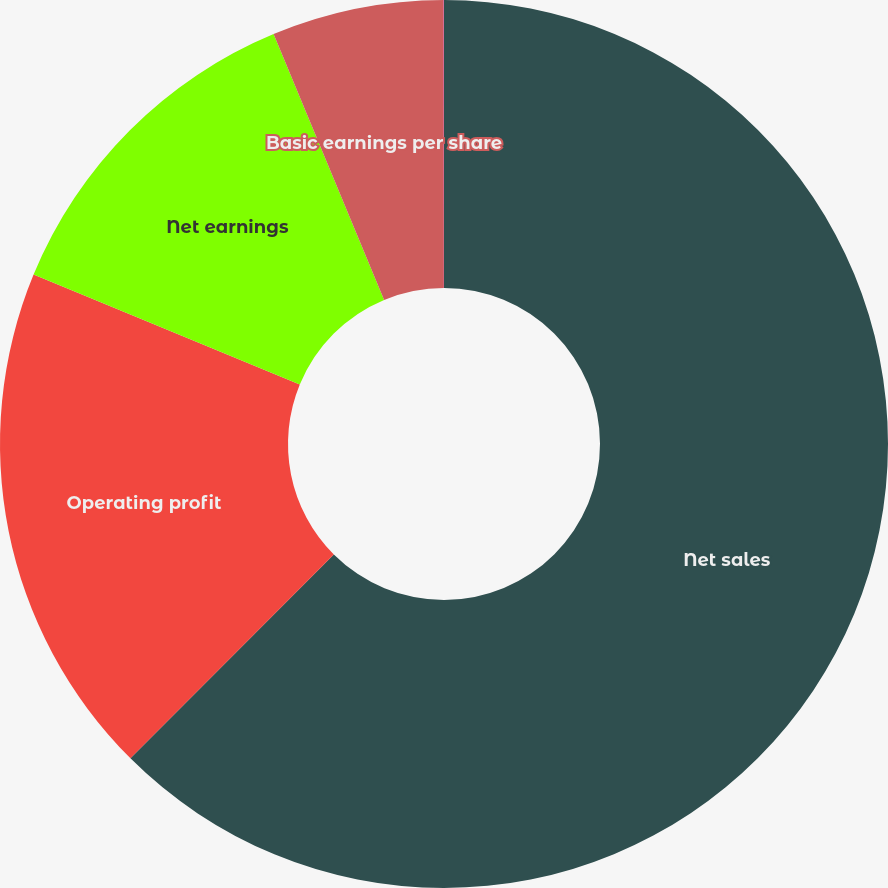<chart> <loc_0><loc_0><loc_500><loc_500><pie_chart><fcel>Net sales<fcel>Operating profit<fcel>Net earnings<fcel>Basic earnings per share<fcel>Diluted earnings per share (a)<nl><fcel>62.48%<fcel>18.75%<fcel>12.5%<fcel>6.26%<fcel>0.01%<nl></chart> 